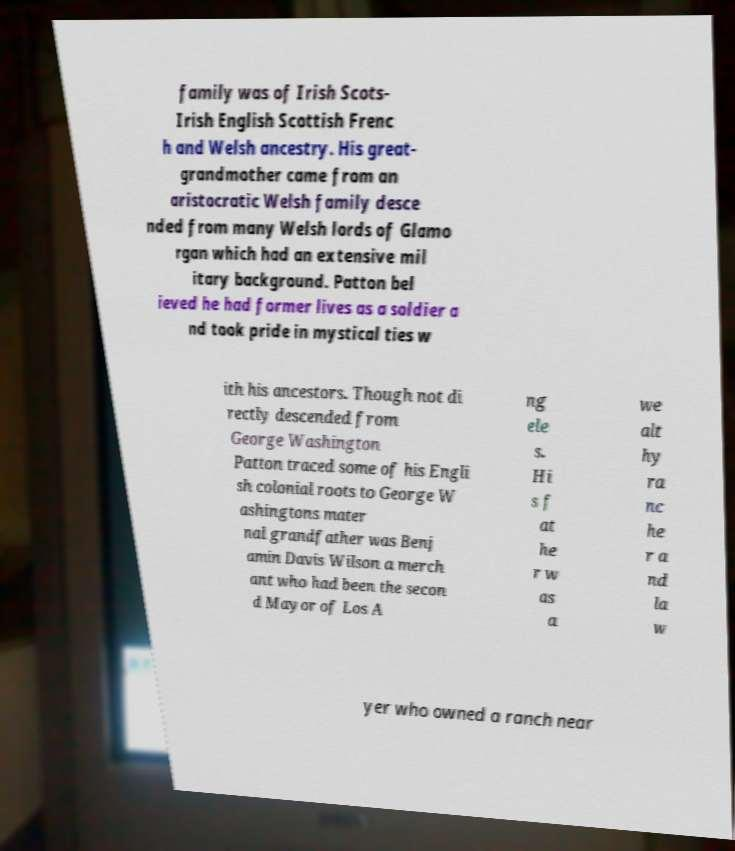What messages or text are displayed in this image? I need them in a readable, typed format. family was of Irish Scots- Irish English Scottish Frenc h and Welsh ancestry. His great- grandmother came from an aristocratic Welsh family desce nded from many Welsh lords of Glamo rgan which had an extensive mil itary background. Patton bel ieved he had former lives as a soldier a nd took pride in mystical ties w ith his ancestors. Though not di rectly descended from George Washington Patton traced some of his Engli sh colonial roots to George W ashingtons mater nal grandfather was Benj amin Davis Wilson a merch ant who had been the secon d Mayor of Los A ng ele s. Hi s f at he r w as a we alt hy ra nc he r a nd la w yer who owned a ranch near 